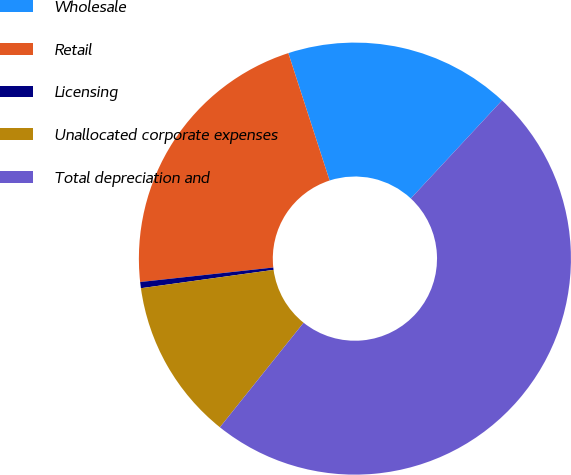Convert chart. <chart><loc_0><loc_0><loc_500><loc_500><pie_chart><fcel>Wholesale<fcel>Retail<fcel>Licensing<fcel>Unallocated corporate expenses<fcel>Total depreciation and<nl><fcel>16.91%<fcel>21.74%<fcel>0.46%<fcel>12.07%<fcel>48.82%<nl></chart> 